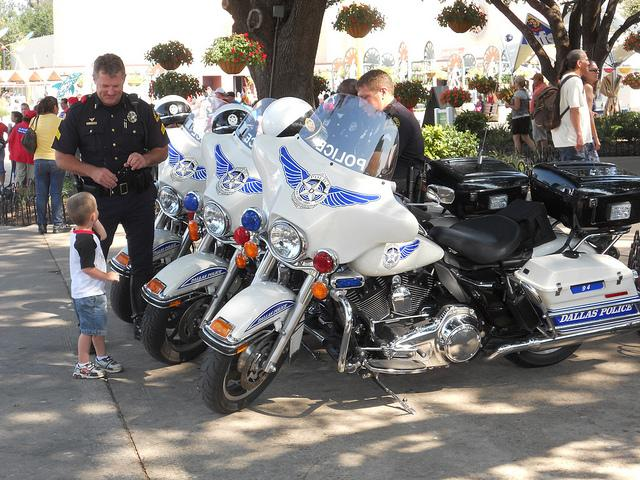What NFL team plays in the town? cowboys 